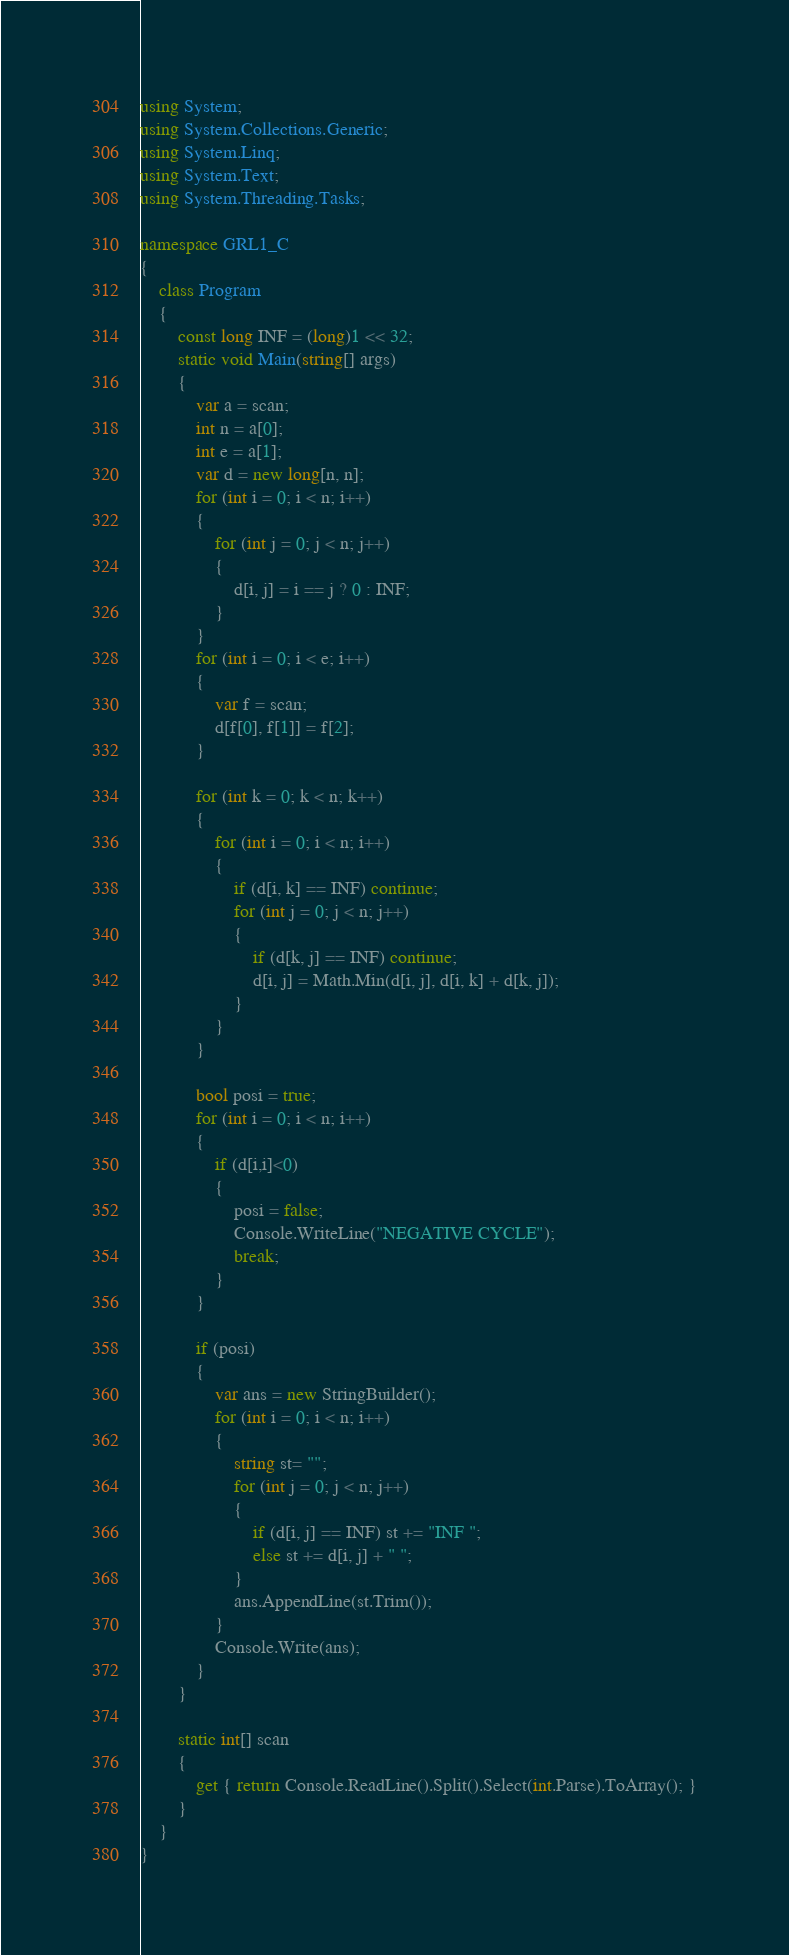Convert code to text. <code><loc_0><loc_0><loc_500><loc_500><_C#_>using System;
using System.Collections.Generic;
using System.Linq;
using System.Text;
using System.Threading.Tasks;

namespace GRL1_C
{
    class Program
    {
        const long INF = (long)1 << 32;
        static void Main(string[] args)
        {
            var a = scan;
            int n = a[0];
            int e = a[1];
            var d = new long[n, n];
            for (int i = 0; i < n; i++)
            {
                for (int j = 0; j < n; j++)
                {
                    d[i, j] = i == j ? 0 : INF; 
                }
            }
            for (int i = 0; i < e; i++)
            {
                var f = scan;
                d[f[0], f[1]] = f[2];
            }

            for (int k = 0; k < n; k++)
            {
                for (int i = 0; i < n; i++)
                {
                    if (d[i, k] == INF) continue;
                    for (int j = 0; j < n; j++)
                    {
                        if (d[k, j] == INF) continue;
                        d[i, j] = Math.Min(d[i, j], d[i, k] + d[k, j]);
                    }
                }
            }

            bool posi = true;
            for (int i = 0; i < n; i++)
            {
                if (d[i,i]<0)
                {
                    posi = false;
                    Console.WriteLine("NEGATIVE CYCLE");
                    break;
                }
            }

            if (posi)
            {
                var ans = new StringBuilder();
                for (int i = 0; i < n; i++)
                {
                    string st= "";
                    for (int j = 0; j < n; j++)
                    {
                        if (d[i, j] == INF) st += "INF ";
                        else st += d[i, j] + " ";
                    }
                    ans.AppendLine(st.Trim());
                }
                Console.Write(ans);
            }
        }

        static int[] scan
        {
            get { return Console.ReadLine().Split().Select(int.Parse).ToArray(); }
        }
    }
}</code> 